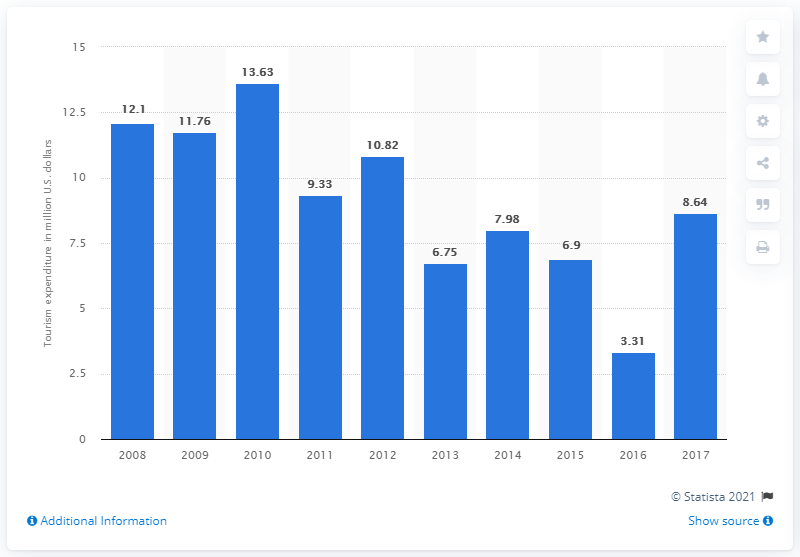Highlight a few significant elements in this photo. In 2016, Egypt's tourism expenditure amounted to 3.31 billion. In 2010, Egypt's tourism expenditure was 10.82 In 2017, Egypt's tourism expenditure in the United States was valued at approximately $8.64 billion. The crash of the Russian plane in 2016 caused a significant decline in tourist arrivals. 